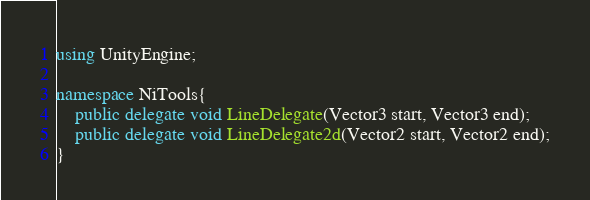Convert code to text. <code><loc_0><loc_0><loc_500><loc_500><_C#_>using UnityEngine;

namespace NiTools{
	public delegate void LineDelegate(Vector3 start, Vector3 end);
	public delegate void LineDelegate2d(Vector2 start, Vector2 end);
}</code> 